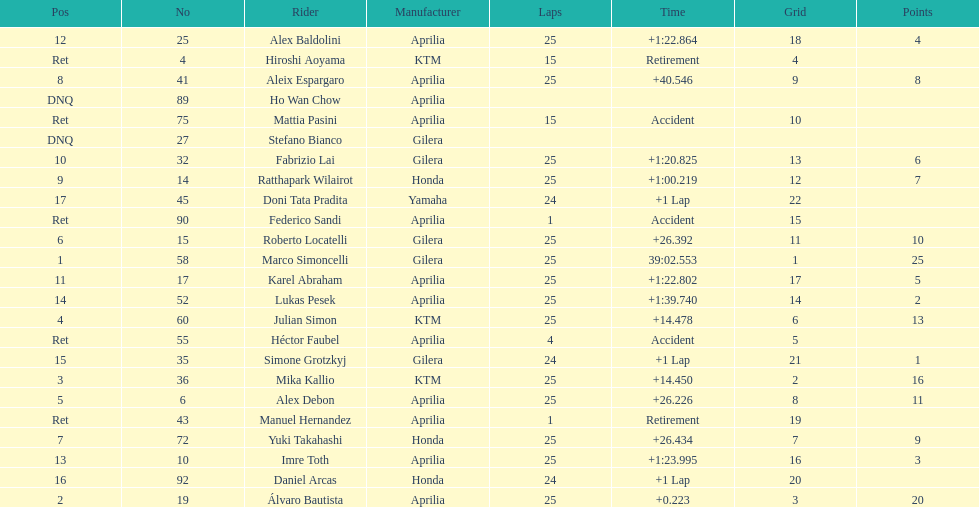The next rider from italy aside from winner marco simoncelli was Roberto Locatelli. 